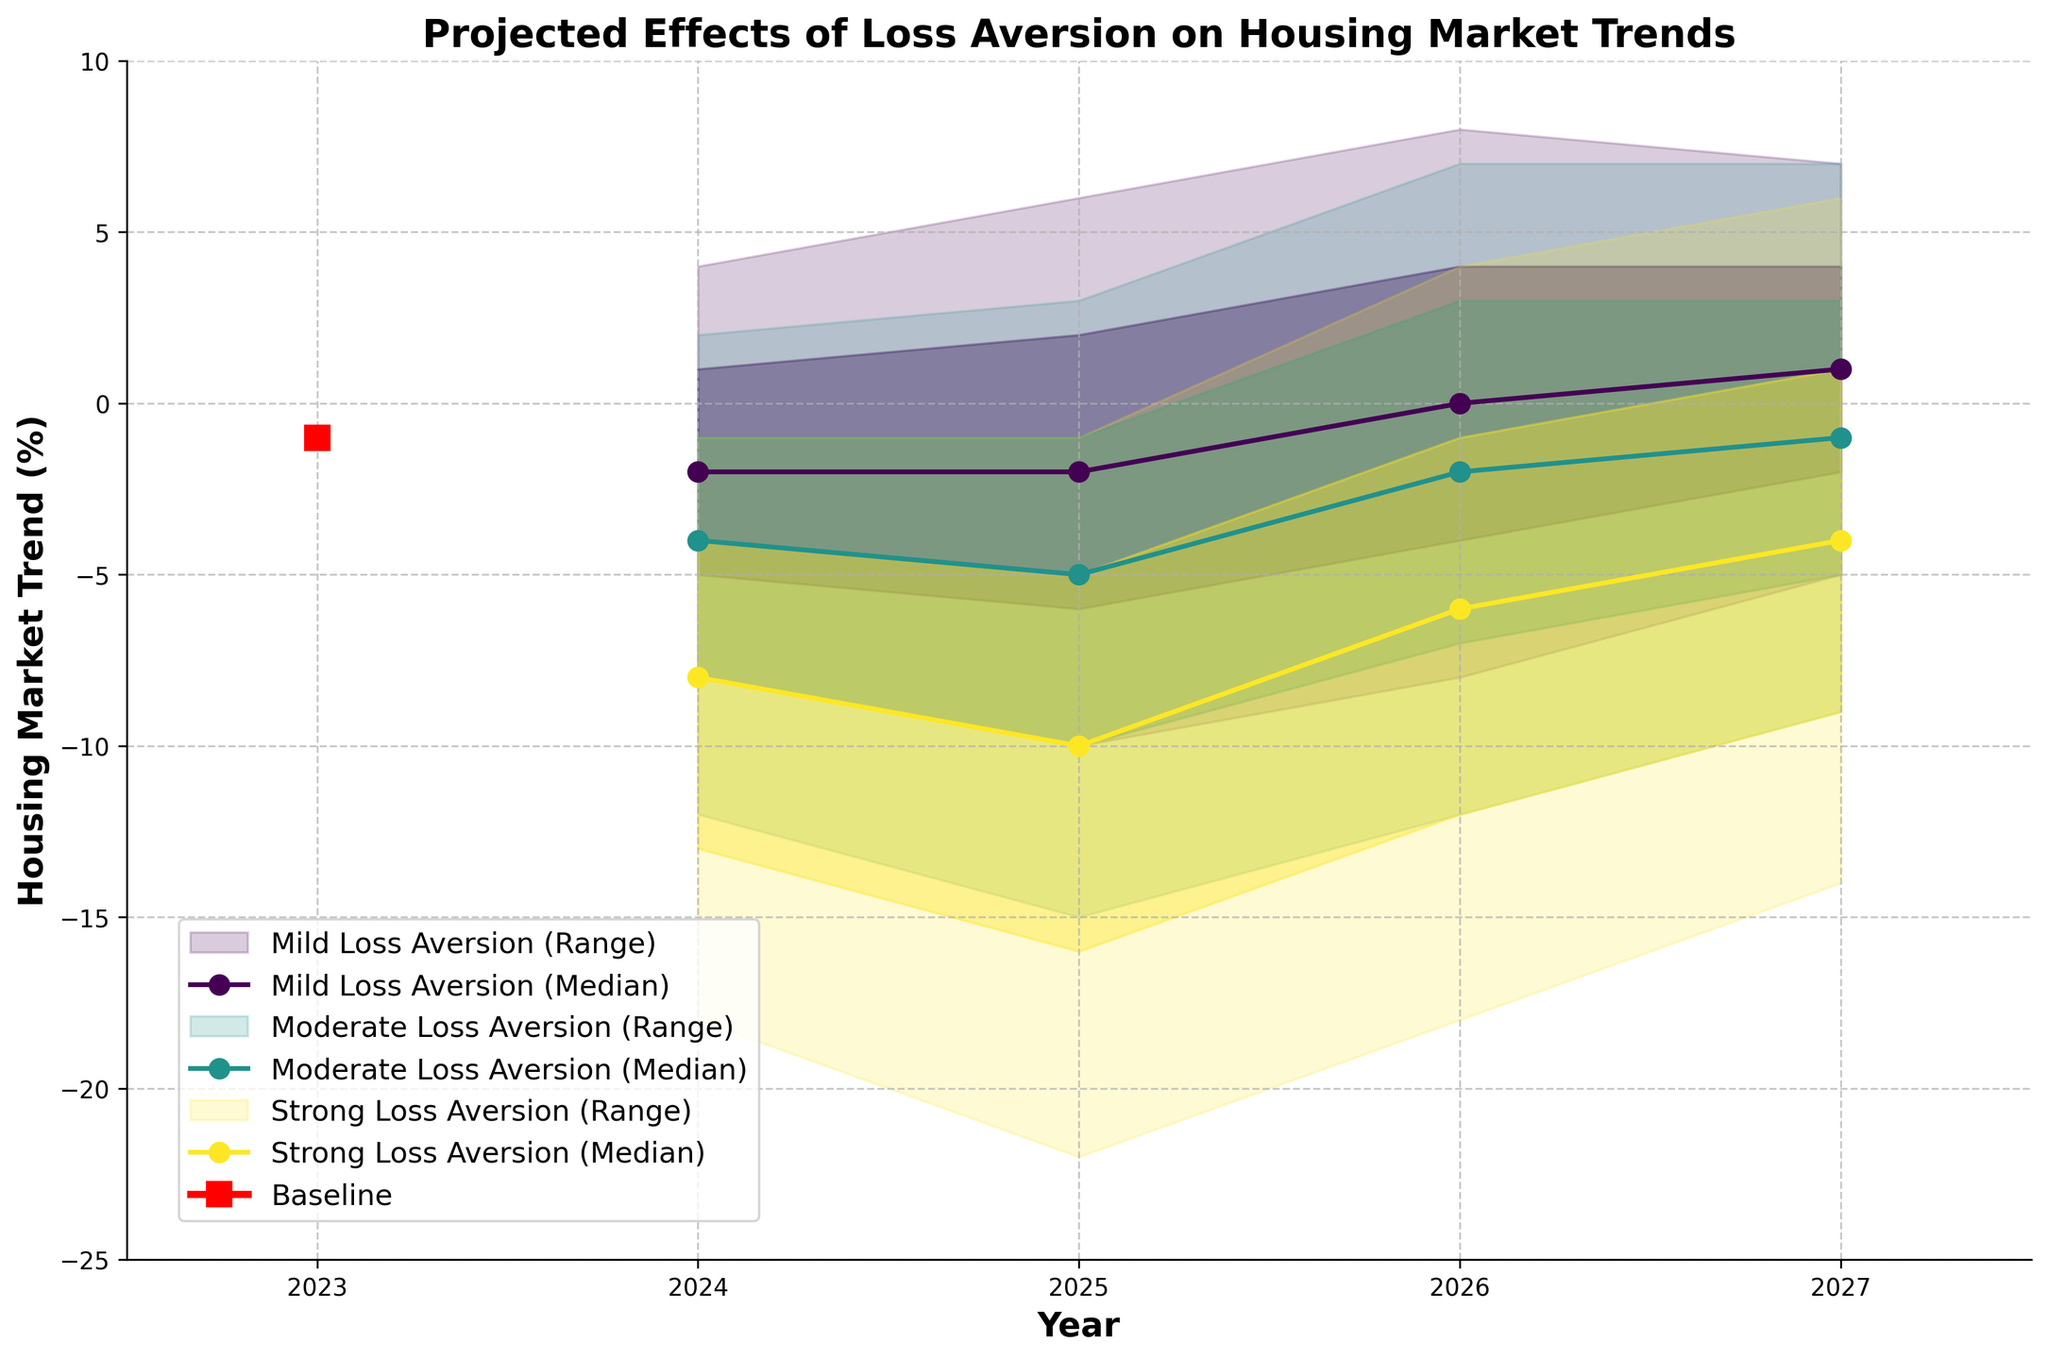What is the title of the figure? The title is usually located at the top of the figure and describes the main topic or focus.
Answer: Projected Effects of Loss Aversion on Housing Market Trends What is the estimated baseline trend for the year 2024? Look at the plot for the year 2024 and identify the value for the Baseline scenario, often highlighted differently.
Answer: -1% How does the median housing market trend compare between the Mild Loss Aversion and Strong Loss Aversion scenarios in 2025? Locate the year 2025 and compare the median (MidEstimate) values of Mild Loss Aversion and Strong Loss Aversion.
Answer: -2% vs. -10% Which scenario shows the greatest range in projections for the year 2026? Identify the scenario where the distance between LowEstimate and HighEstimate is largest for the year 2026.
Answer: Strong Loss Aversion What is the general trend direction of the median housing market values for the Baseline scenario? Observe the trajectory of the MidEstimate values for the Baseline scenario from 2023 to 2027.
Answer: Increasing What is the highest positive projected value for the year 2026, and under which scenario does it occur? Look for the maximum value in 2026 on the plot and identify the corresponding scenario.
Answer: 8% in Mild Loss Aversion Compare the housing market trend ranges for Moderate Loss Aversion in 2024 and 2027. Which year shows a wider spread? Calculate the difference between HighEstimate and LowEstimate for Moderate Loss Aversion in both years and compare them.
Answer: 2024 (range is 14) vs 2027 (range is 16); 2027 shows a wider spread By how much does the median value change for Strong Loss Aversion from 2024 to 2025? Find the Median (MidEstimate) values for Strong Loss Aversion in 2024 and 2025, then subtract the 2024 value from the 2025 value.
Answer: -10 - (-8) = -2% What is the overall trend in the housing market for Strong Loss Aversion over the five years? Analyze the MidEstimate values for Strong Loss Aversion from 2023 to 2027 to identify the overall direction.
Answer: Increasing (from -8% to -4%) Which scenario appears to be the least pessimistic in 2027 based on the median projections? Compare the MidEstimate values of different scenarios for the year 2027.
Answer: Mild Loss Aversion 